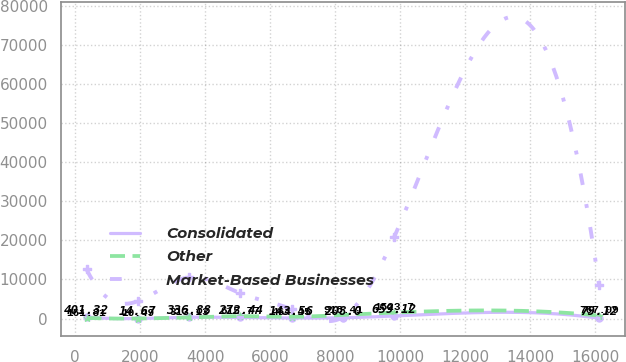Convert chart to OTSL. <chart><loc_0><loc_0><loc_500><loc_500><line_chart><ecel><fcel>Consolidated<fcel>Other<fcel>Market-Based Businesses<nl><fcel>352.36<fcel>401.32<fcel>161.81<fcel>12596.1<nl><fcel>1928.27<fcel>14.67<fcel>10.49<fcel>4431.06<nl><fcel>3504.18<fcel>336.88<fcel>313.13<fcel>10554.9<nl><fcel>5080.09<fcel>272.44<fcel>615.77<fcel>6472.33<nl><fcel>6656<fcel>143.56<fcel>464.45<fcel>2389.79<nl><fcel>8231.91<fcel>208<fcel>918.41<fcel>348.52<nl><fcel>9807.82<fcel>659.12<fcel>1523.7<fcel>20761.2<nl><fcel>16111.5<fcel>79.12<fcel>767.09<fcel>8513.6<nl></chart> 